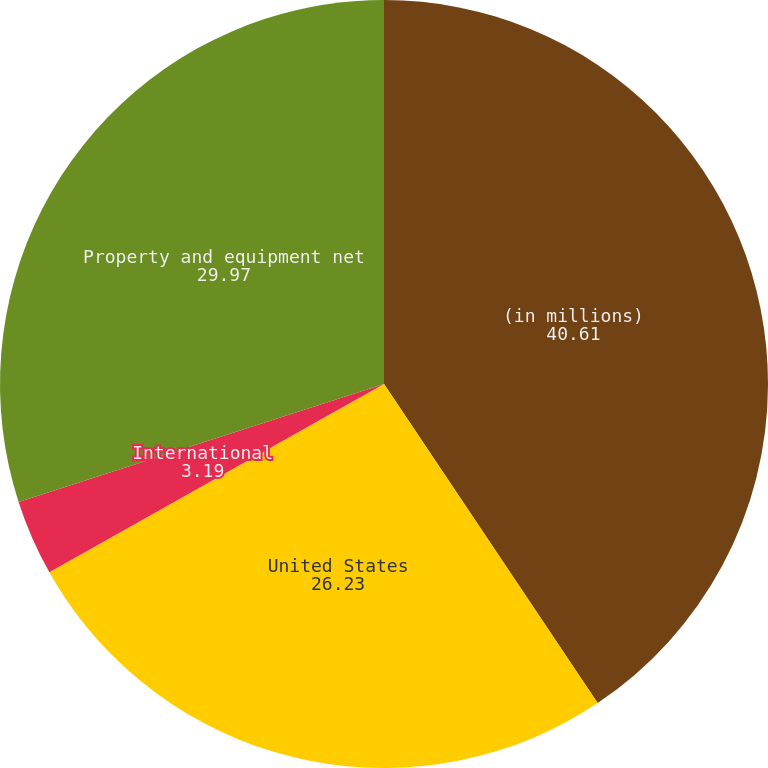Convert chart. <chart><loc_0><loc_0><loc_500><loc_500><pie_chart><fcel>(in millions)<fcel>United States<fcel>International<fcel>Property and equipment net<nl><fcel>40.61%<fcel>26.23%<fcel>3.19%<fcel>29.97%<nl></chart> 